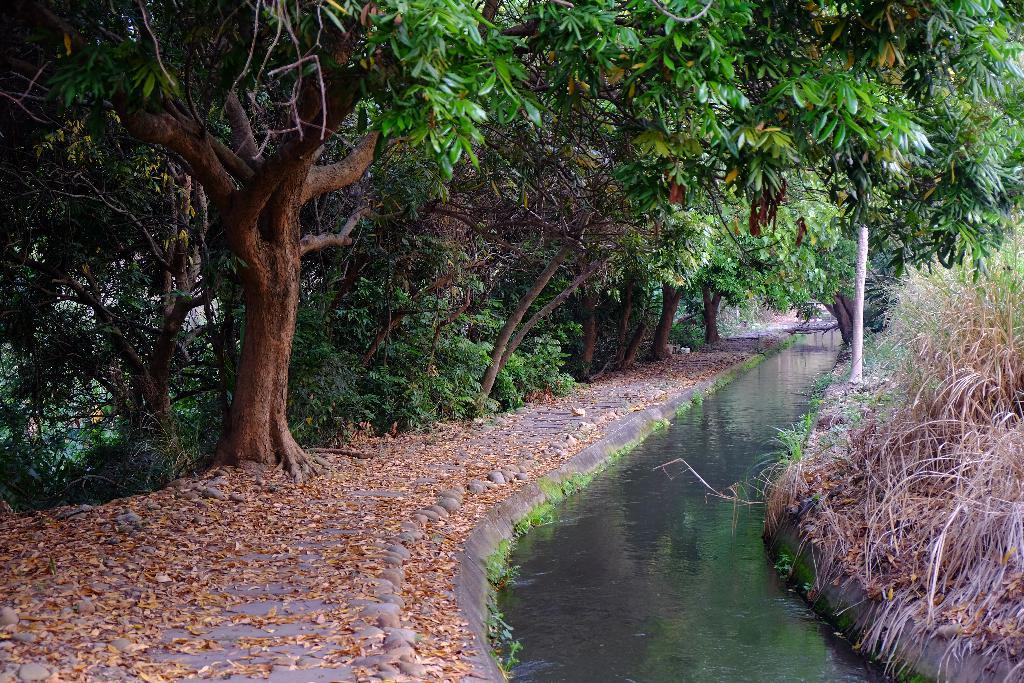What is the primary element visible in the image? There is water in the image. Where are the trees located in the image? The trees are in the left corner of the image. What type of plant is growing on the list in the image? There is no list or plant growing on a list present in the image. 